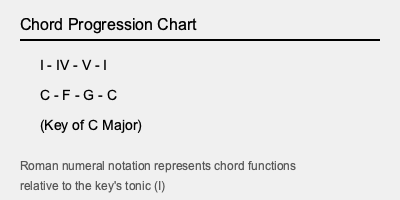In the chord progression chart shown above, what does the Roman numeral "IV" represent in the key of C Major? To understand what the Roman numeral "IV" represents in this chord progression:

1. Identify the key: The chart shows we're in the key of C Major.

2. Understand Roman numeral notation:
   - In this system, each scale degree is represented by a Roman numeral.
   - The numbers correspond to the position of the note in the scale.

3. Count scale degrees in C Major:
   C (I) - D (II) - E (III) - F (IV) - G (V) - A (VI) - B (VII)

4. Locate the IV chord:
   - IV is the 4th scale degree.
   - In C Major, the 4th note is F.

5. Build the chord:
   - Major chords on major scale degrees are represented by uppercase numerals.
   - Therefore, IV in this context is an F Major chord.

6. Confirm with the chart:
   The progression shows C - F - G - C, where F indeed corresponds to IV.

Thus, in the key of C Major, the Roman numeral IV represents the F Major chord.
Answer: F Major chord 